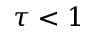<formula> <loc_0><loc_0><loc_500><loc_500>\tau < 1</formula> 